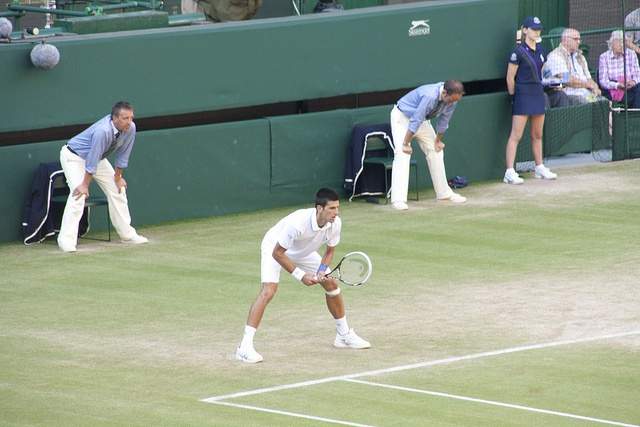Describe the objects in this image and their specific colors. I can see people in gray, white, darkgray, and tan tones, people in gray, white, and darkgray tones, people in gray, white, and darkgray tones, people in gray, navy, darkblue, and tan tones, and chair in gray, black, teal, and navy tones in this image. 